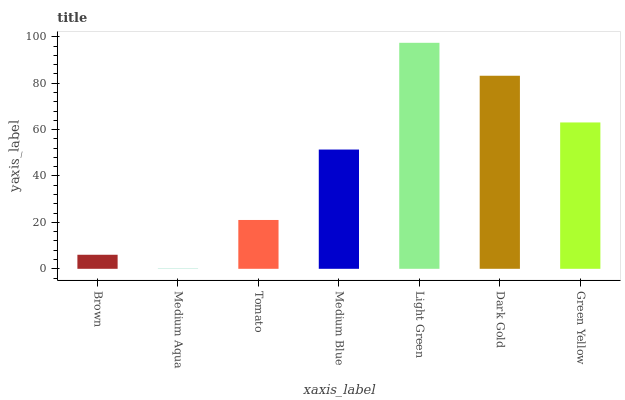Is Medium Aqua the minimum?
Answer yes or no. Yes. Is Light Green the maximum?
Answer yes or no. Yes. Is Tomato the minimum?
Answer yes or no. No. Is Tomato the maximum?
Answer yes or no. No. Is Tomato greater than Medium Aqua?
Answer yes or no. Yes. Is Medium Aqua less than Tomato?
Answer yes or no. Yes. Is Medium Aqua greater than Tomato?
Answer yes or no. No. Is Tomato less than Medium Aqua?
Answer yes or no. No. Is Medium Blue the high median?
Answer yes or no. Yes. Is Medium Blue the low median?
Answer yes or no. Yes. Is Green Yellow the high median?
Answer yes or no. No. Is Medium Aqua the low median?
Answer yes or no. No. 